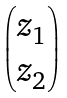Convert formula to latex. <formula><loc_0><loc_0><loc_500><loc_500>\begin{pmatrix} z _ { 1 } \\ z _ { 2 } \end{pmatrix}</formula> 